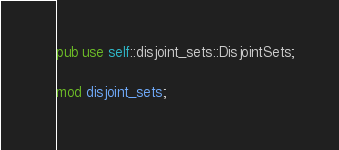Convert code to text. <code><loc_0><loc_0><loc_500><loc_500><_Rust_>
pub use self::disjoint_sets::DisjointSets;

mod disjoint_sets;

</code> 